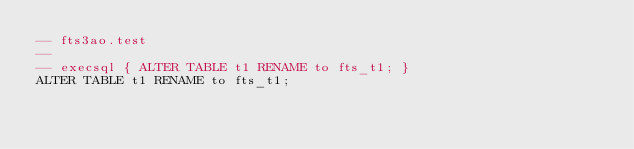<code> <loc_0><loc_0><loc_500><loc_500><_SQL_>-- fts3ao.test
-- 
-- execsql { ALTER TABLE t1 RENAME to fts_t1; }
ALTER TABLE t1 RENAME to fts_t1;</code> 